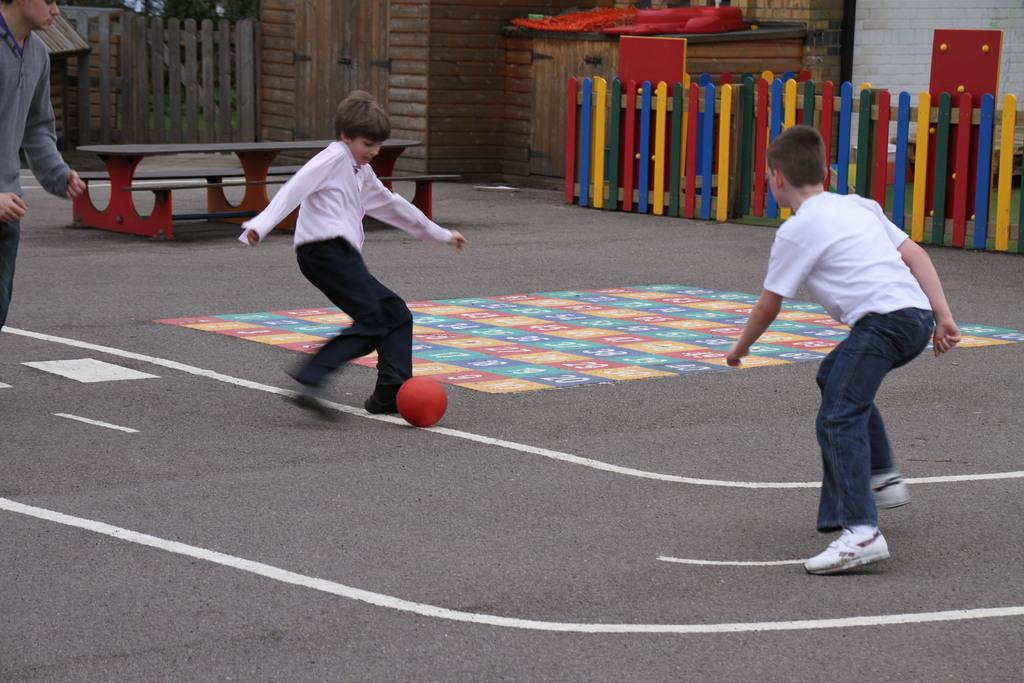How many kids are in the image? There are two kids in the image. What are the kids doing in the image? The kids are playing with a ball. What can be seen in the background of the image? There is a fence, a wall, and a table in the background of the image. Where is the nearest market to the location of the kids in the image? There is no information about a market in the image, so it cannot be determined from the image. 